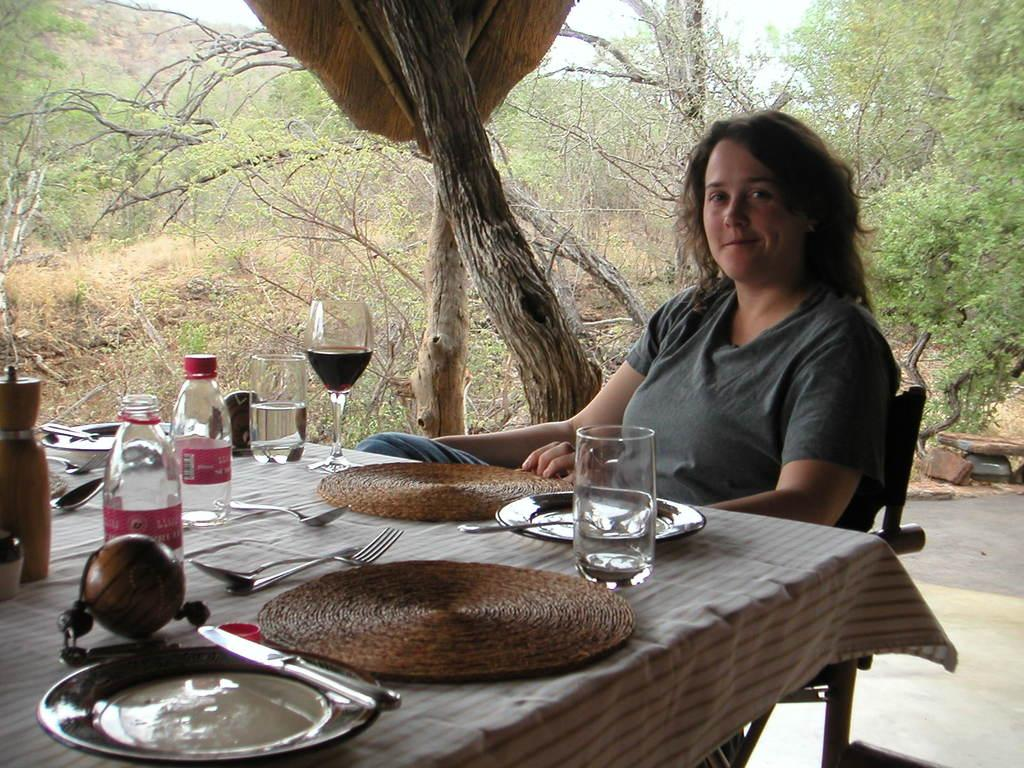What is the woman in the image doing? The woman is sitting on a chair in the image. What is in front of the woman? There is a table in front of the woman. What items can be seen on the table? Carpets, a plate, a knife, bottles, spoons, and glasses are on the table. What is visible in the background of the image? Trees are visible in the image. What type of knowledge can be gained from the key on the table in the image? There is no key present in the image; only carpets, a plate, a knife, bottles, spoons, and glasses are on the table. What reaction can be observed from the woman when she discovers the reaction on the table? There is no reaction present in the image; the woman is simply sitting on a chair. 